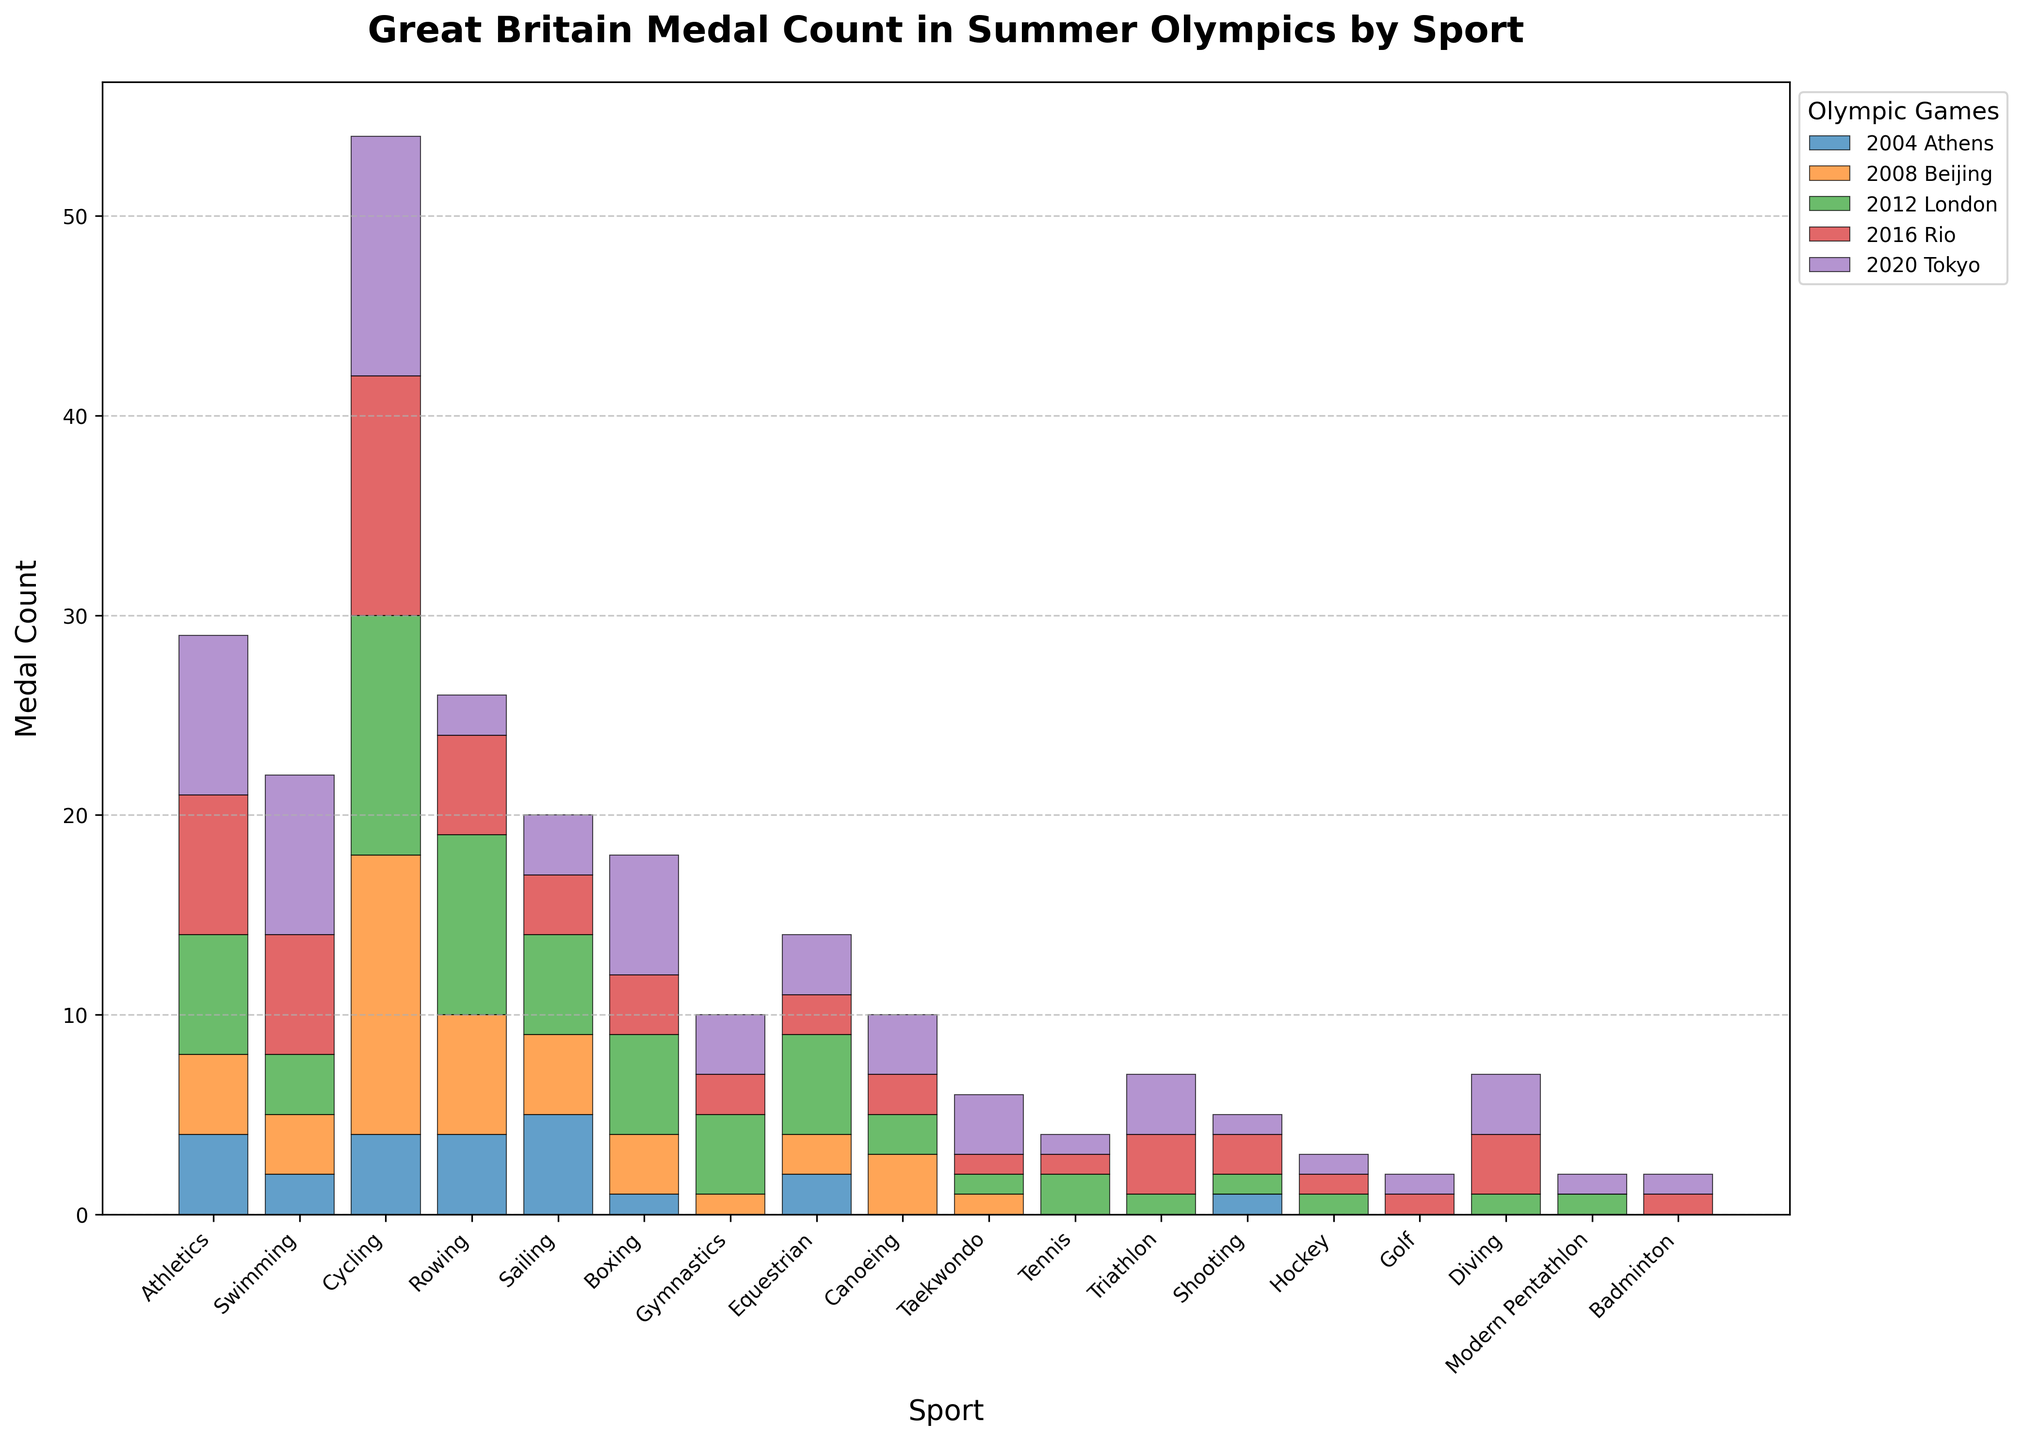What sport has the most consistent medal count across the five Olympics? To determine the most consistent sport, look at the bars for each sport and see which has the least variation in height. Rowing or Cycling shows significant variation, whereas Athletics shows more consistent bar heights.
Answer: Athletics Which Olympic year contributed the most to Great Britain's total medal count in Cycling? By examining the height of the bars for Cycling across the years, the highest bar is for 2008 Beijing.
Answer: 2008 Beijing How many total medals did Great Britain win in Equestrian across the five Olympics? Adding up the medal counts for Equestrian: 2 (2004) + 2 (2008) + 5 (2012) + 2 (2016) + 3 (2020) gives 14.
Answer: 14 Between 2004 and 2020, how did the medal count trend for Swimming evolve? The trend can be seen by comparing the heights of the bars for Swimming from 2004 to 2020, which show an increasing pattern: 2, 3, 3, 6, 8.
Answer: Increasing Which sport had a significant increase in medals from 2004 to 2008? Notice the differences in the bar heights between 2004 and 2008. Cycling had a noticeable increase from 4 medals in 2004 to 14 in 2008.
Answer: Cycling In 2020, which two sports had an equal medal count? Compare the heights of the bars for different sports in 2020. Canoeing, Diving, Gymnastics, and Taekwondo all have bars extending to 3.
Answer: Canoeing and Diving (or any other with 3) Was there any sport that won medals in 2020 but did not win any in 2004? Checking bars for each sport in 2004 and 2020, sports like Gymnastics, Taekwondo, and Triathlon had zero medals in 2004 and more in 2020.
Answer: Gymnastics, Taekwondo, Triathlon How did the medal count for Rowing change from 2012 to 2020? Comparing the bar heights for Rowing in 2012 (9), 2016 (5), and 2020 (2), the count decreased gradually.
Answer: Decreased Which sport saw the highest number of medals in any single Olympic year? By analyzing the height of all bars, Cycling in 2008 Beijing with 14 medals stands out as the highest in a single year.
Answer: Cycling (2008) 